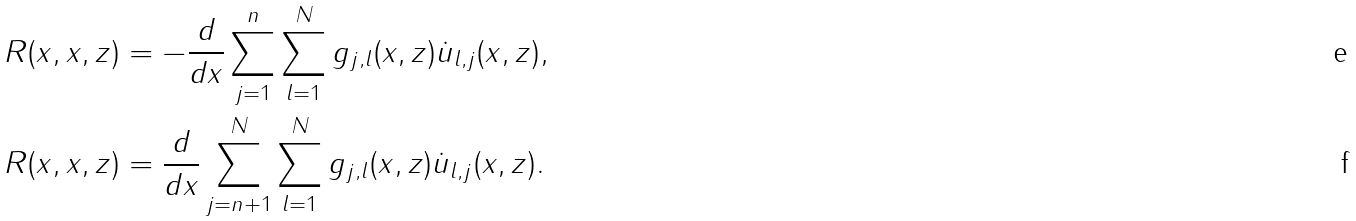Convert formula to latex. <formula><loc_0><loc_0><loc_500><loc_500>R ( x , x , z ) & = - \frac { d } { d x } \sum _ { j = 1 } ^ { n } \sum _ { l = 1 } ^ { N } g _ { j , l } ( x , z ) \dot { u } _ { l , j } ( x , z ) , \\ R ( x , x , z ) & = \frac { d } { d x } \sum _ { j = n + 1 } ^ { N } \sum _ { l = 1 } ^ { N } g _ { j , l } ( x , z ) \dot { u } _ { l , j } ( x , z ) .</formula> 